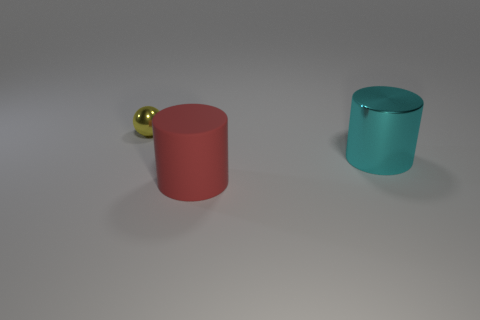Add 2 big red matte things. How many objects exist? 5 Subtract all spheres. How many objects are left? 2 Add 3 metallic cylinders. How many metallic cylinders are left? 4 Add 3 small red matte cylinders. How many small red matte cylinders exist? 3 Subtract 0 cyan blocks. How many objects are left? 3 Subtract all large green rubber blocks. Subtract all big red rubber cylinders. How many objects are left? 2 